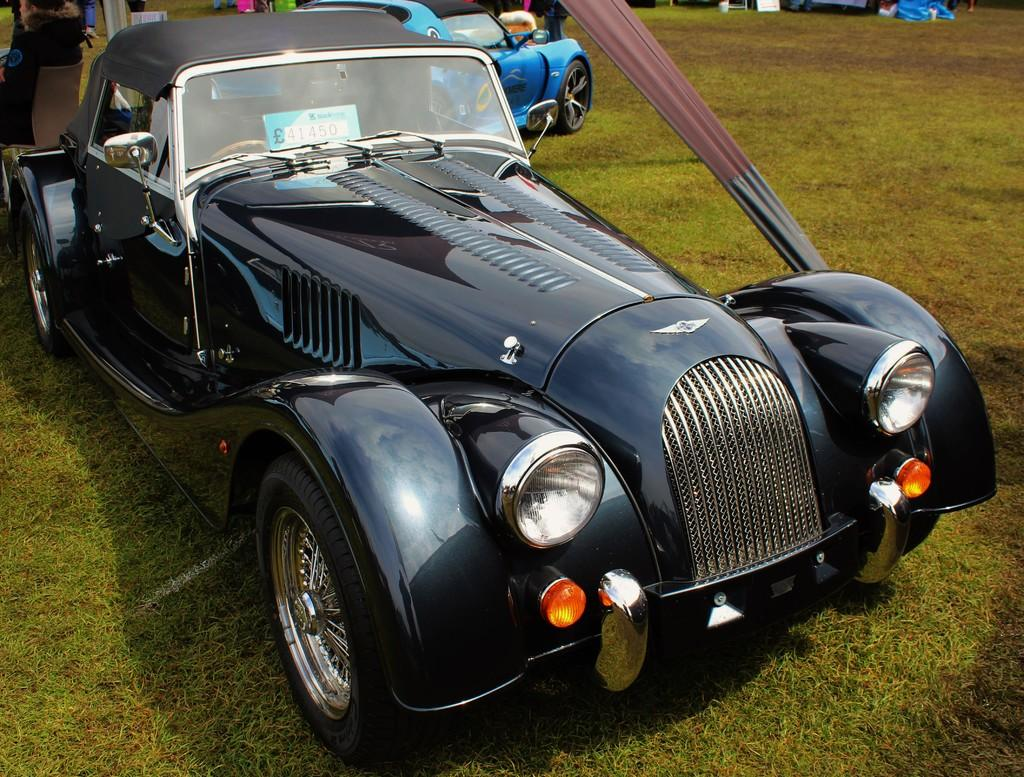What type of vehicles can be seen in the image? There are cars in the image. What type of vegetation is visible at the bottom of the image? There is grass visible at the bottom of the image. How many cars can be seen in the image? There are other cars visible in the image. What type of produce is being sold at the door in the image? There is no produce or door present in the image; it features cars and grass. 